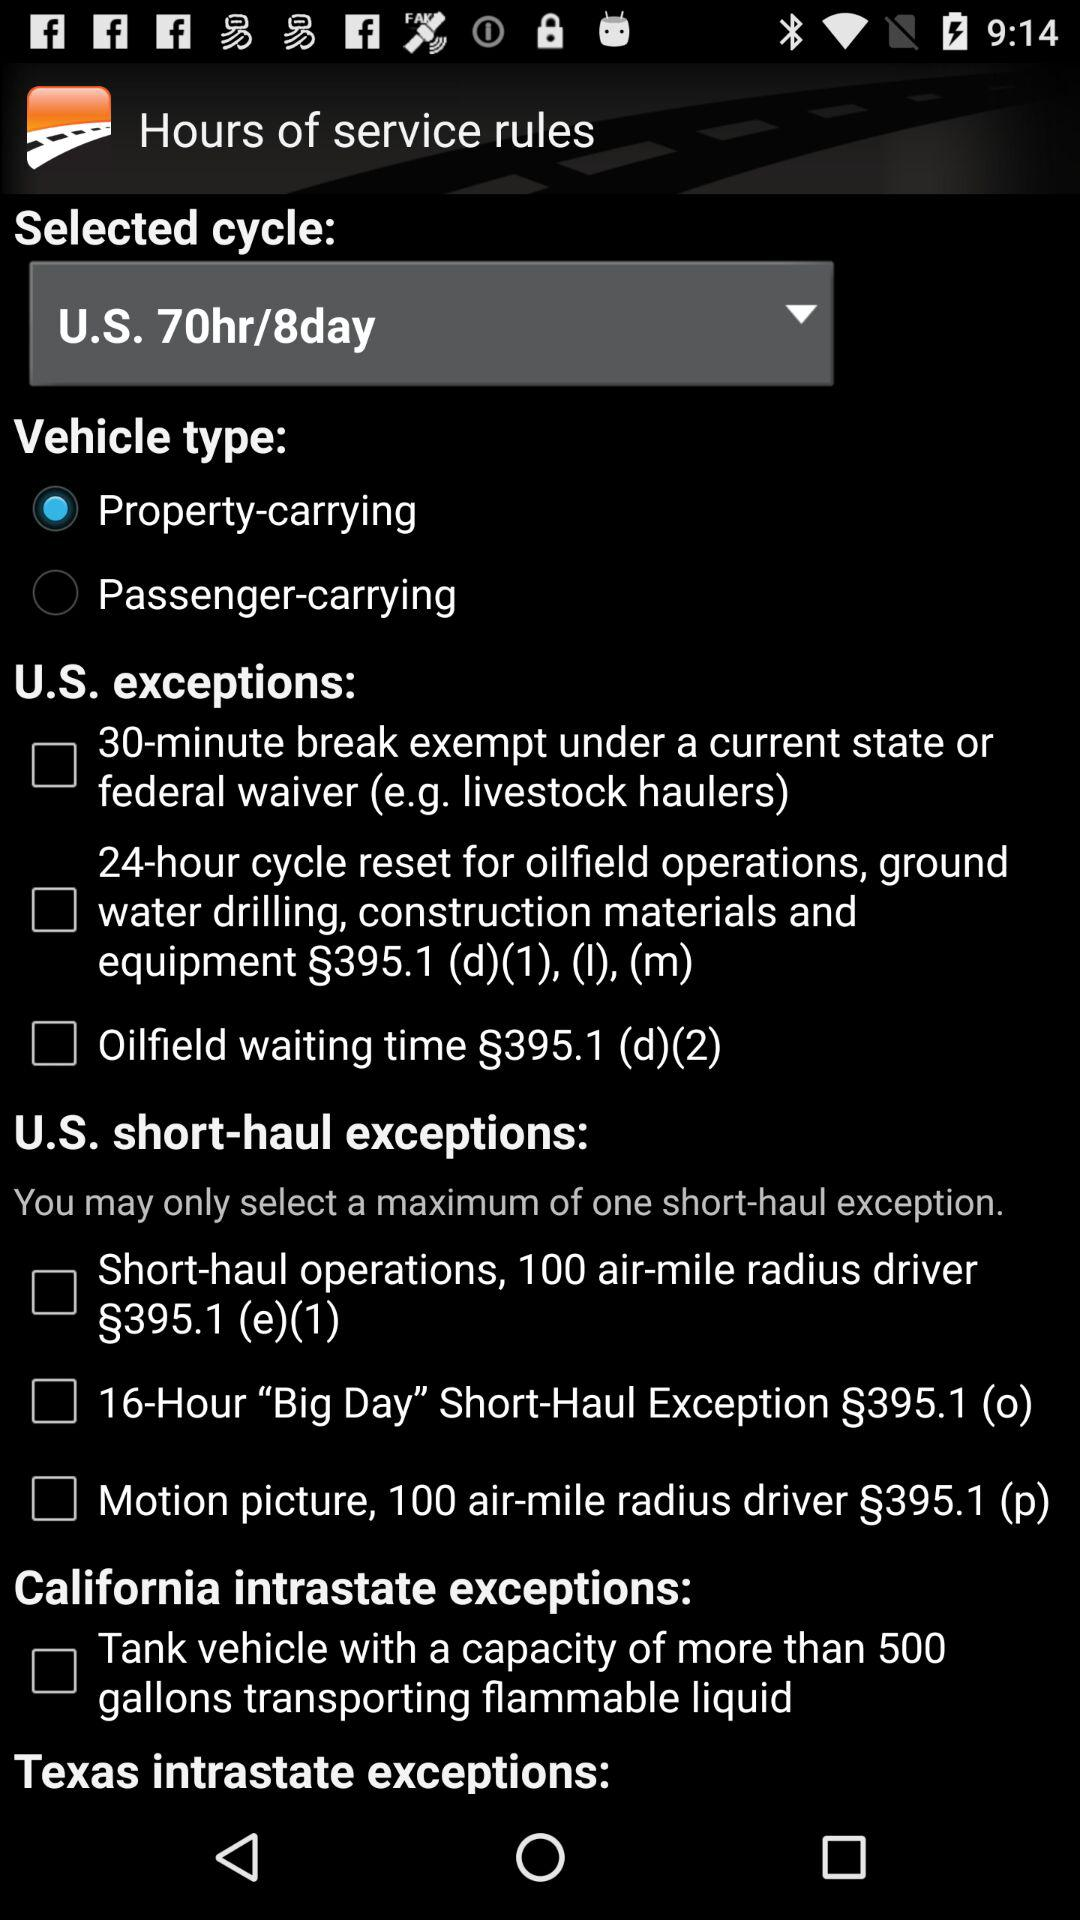What cycle is selected? The selected cycle is "U.S. 70hr/8day". 